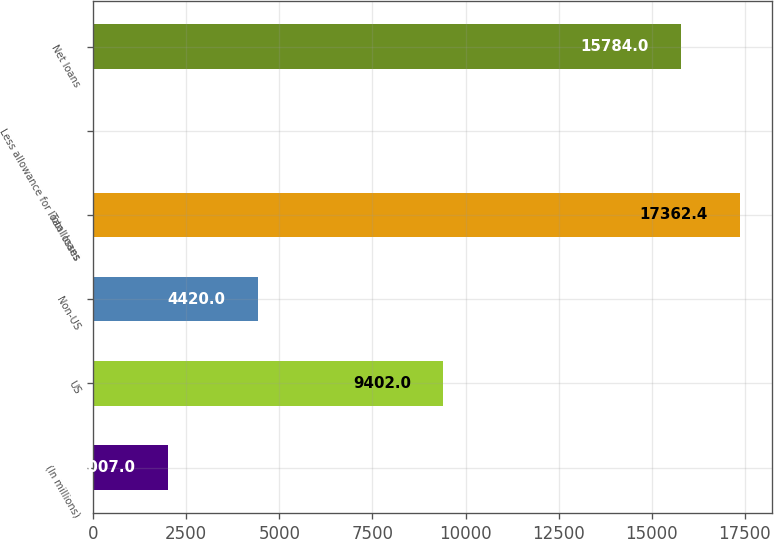Convert chart to OTSL. <chart><loc_0><loc_0><loc_500><loc_500><bar_chart><fcel>(In millions)<fcel>US<fcel>Non-US<fcel>Total loans<fcel>Less allowance for loan losses<fcel>Net loans<nl><fcel>2007<fcel>9402<fcel>4420<fcel>17362.4<fcel>18<fcel>15784<nl></chart> 